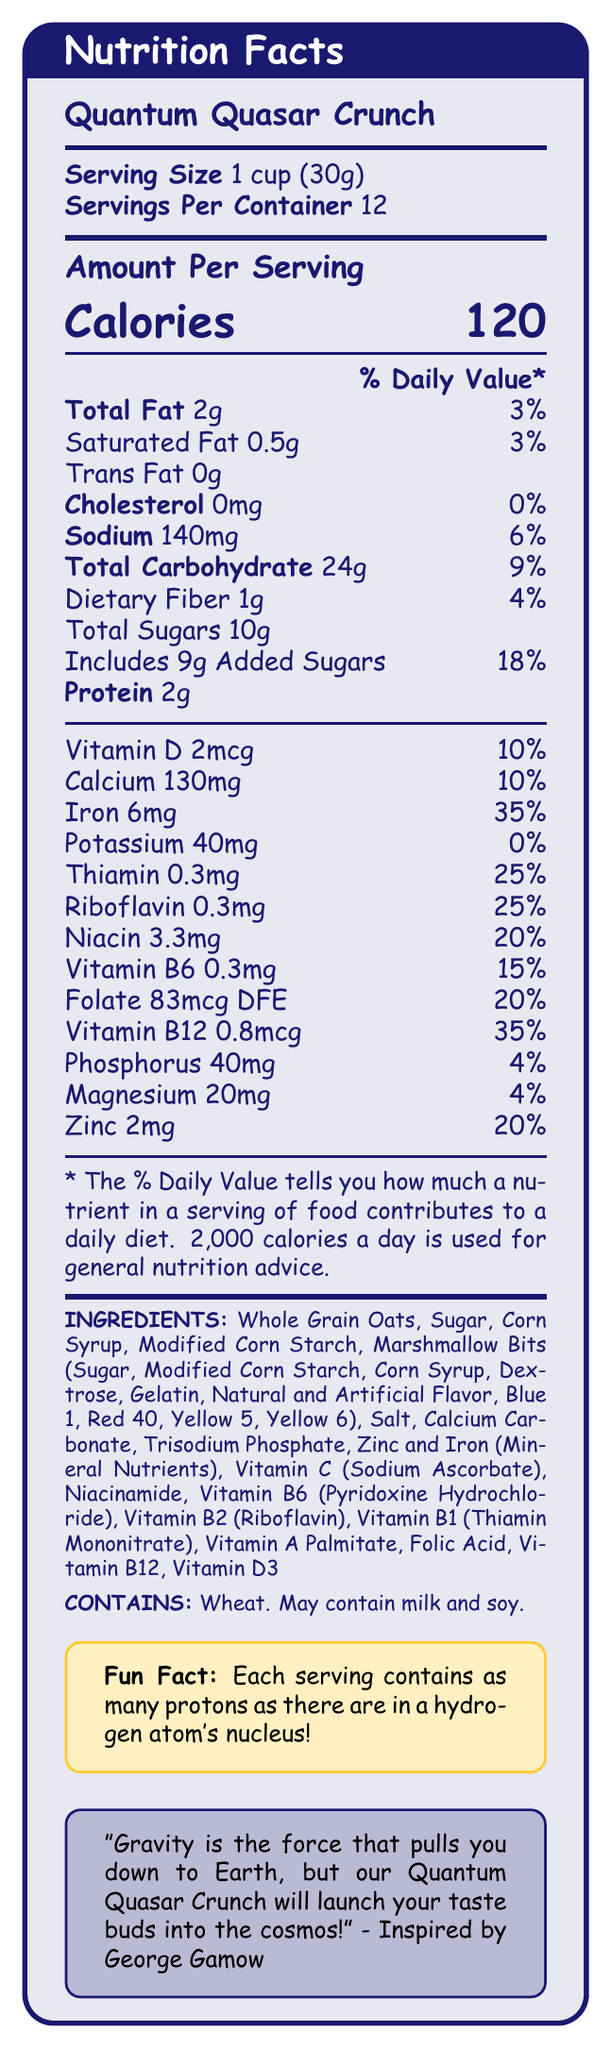what is the product name? The product name is clearly stated at the top of the document as "Quantum Quasar Crunch".
Answer: Quantum Quasar Crunch what is the serving size? The serving size is mentioned in the document right after the product name as "1 cup (30g)".
Answer: 1 cup (30g) how many calories are in one serving? The amount of calories per serving is displayed prominently next to "Calories" in the "Amount Per Serving" section.
Answer: 120 how much saturated fat is in one serving? In the "Amount Per Serving" section, saturated fat is listed as 0.5g with a daily value of 3%.
Answer: 0.5g what is the daily value percentage for iron? The daily value percentage for iron is listed as 35% in the section that details vitamins and minerals.
Answer: 35% how many servings are in one container? A. 10 B. 12 C. 15 The document specifies "Servings Per Container" as 12, indicating that there are 12 servings in one container.
Answer: B which ingredient is not listed? A. Whole Grain Oats B. Sugar C. Honey D. Corn Syrup The list of ingredients does not mention honey, so the correct answer is C.
Answer: C is there any trans fat in the cereal? The document states that there are 0g of trans fat in one serving of the cereal.
Answer: No summarize the main idea of the document. The document is a detailed Nutrition Facts label for Quantum Quasar Crunch. It provides key nutritional information, including vitamins, minerals, and ingredients. The design incorporates space-themed elements and includes a fun fact and a quote inspired by George Gamow.
Answer: This document provides the Nutrition Facts for Quantum Quasar Crunch, a space-themed breakfast cereal. It lists information including serving size, calories, amounts and daily values of various fats, sugars, protein, vitamins, and minerals. It also includes a list of ingredients, allergen information, and a fun fact related to the cereal's theme. Additionally, there is a motivational quote inspired by physicist George Gamow. how much protein does one serving contain? The document states that each serving contains 2g of protein in the "Amount Per Serving" section.
Answer: 2g what percentage of daily value for calcium does one serving provide? In the section detailing vitamins and minerals, calcium is listed as providing 10% of the daily value per serving.
Answer: 10% what is the fun fact about the cereal? The fun fact shown in a separate highlighted box states, "Each serving contains as many protons as there are in a hydrogen atom's nucleus!"
Answer: Each serving contains as many protons as there are in a hydrogen atom's nucleus! is the amount of sodium per serving more than 100mg? The "Amount Per Serving" section lists the sodium content as 140mg, which is more than 100mg.
Answer: Yes does the cereal contain Vitamin B6? Vitamin B6 is listed in the section detailing vitamins and minerals with an amount of 0.3mg and a daily value of 15%.
Answer: Yes what are the colors used in the marshmallow bits? The document lists the specific colors used in the marshmallow bits as Blue 1, Red 40, Yellow 5, and Yellow 6 in the ingredients section.
Answer: Blue 1, Red 40, Yellow 5, Yellow 6 how is the quote related to George Gamow? The quote creatively combines the space theme with George Gamow's notable skill in making complex ideas understandable and enjoyable.
Answer: The quote is inspired by George Gamow's ability to explain complex physics concepts in simple terms, with a focus on how the cereal will "launch your taste buds into the cosmos". 